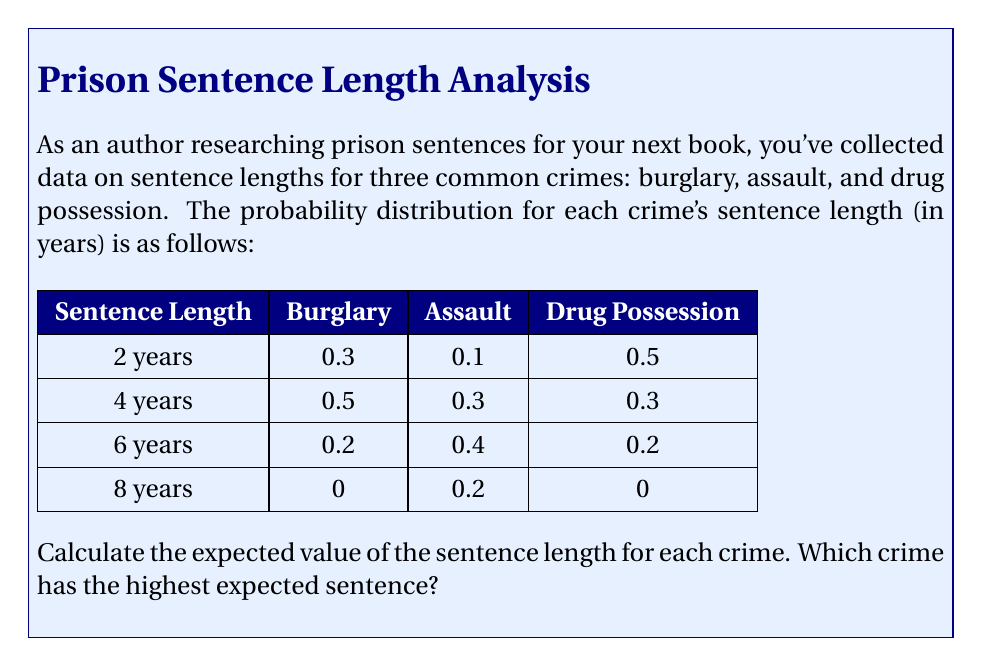Can you solve this math problem? To solve this problem, we need to calculate the expected value for each crime's sentence length. The expected value is the sum of each possible outcome multiplied by its probability.

Let's calculate the expected value for each crime:

1. Burglary:
   $E(\text{Burglary}) = (2 \times 0.3) + (4 \times 0.5) + (6 \times 0.2) + (8 \times 0)$
   $= 0.6 + 2 + 1.2 + 0 = 3.8$ years

2. Assault:
   $E(\text{Assault}) = (2 \times 0.1) + (4 \times 0.3) + (6 \times 0.4) + (8 \times 0.2)$
   $= 0.2 + 1.2 + 2.4 + 1.6 = 5.4$ years

3. Drug Possession:
   $E(\text{Drug Possession}) = (2 \times 0.5) + (4 \times 0.3) + (6 \times 0.2) + (8 \times 0)$
   $= 1 + 1.2 + 1.2 + 0 = 3.4$ years

Comparing the expected values:
Burglary: 3.8 years
Assault: 5.4 years
Drug Possession: 3.4 years

The crime with the highest expected sentence is Assault at 5.4 years.
Answer: Assault has the highest expected sentence at 5.4 years. 